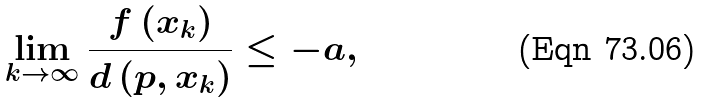Convert formula to latex. <formula><loc_0><loc_0><loc_500><loc_500>\lim _ { k \to \infty } \frac { f \left ( x _ { k } \right ) } { d \left ( p , x _ { k } \right ) } \leq - a ,</formula> 